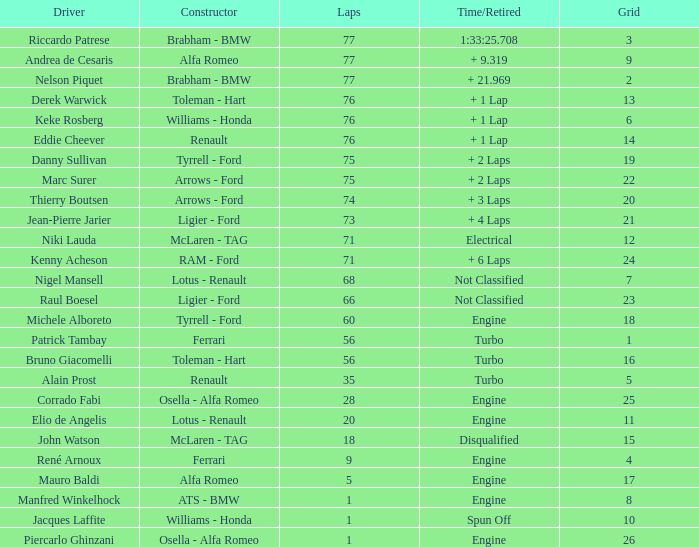Who operated the car with the grid 10 designation? Jacques Laffite. 